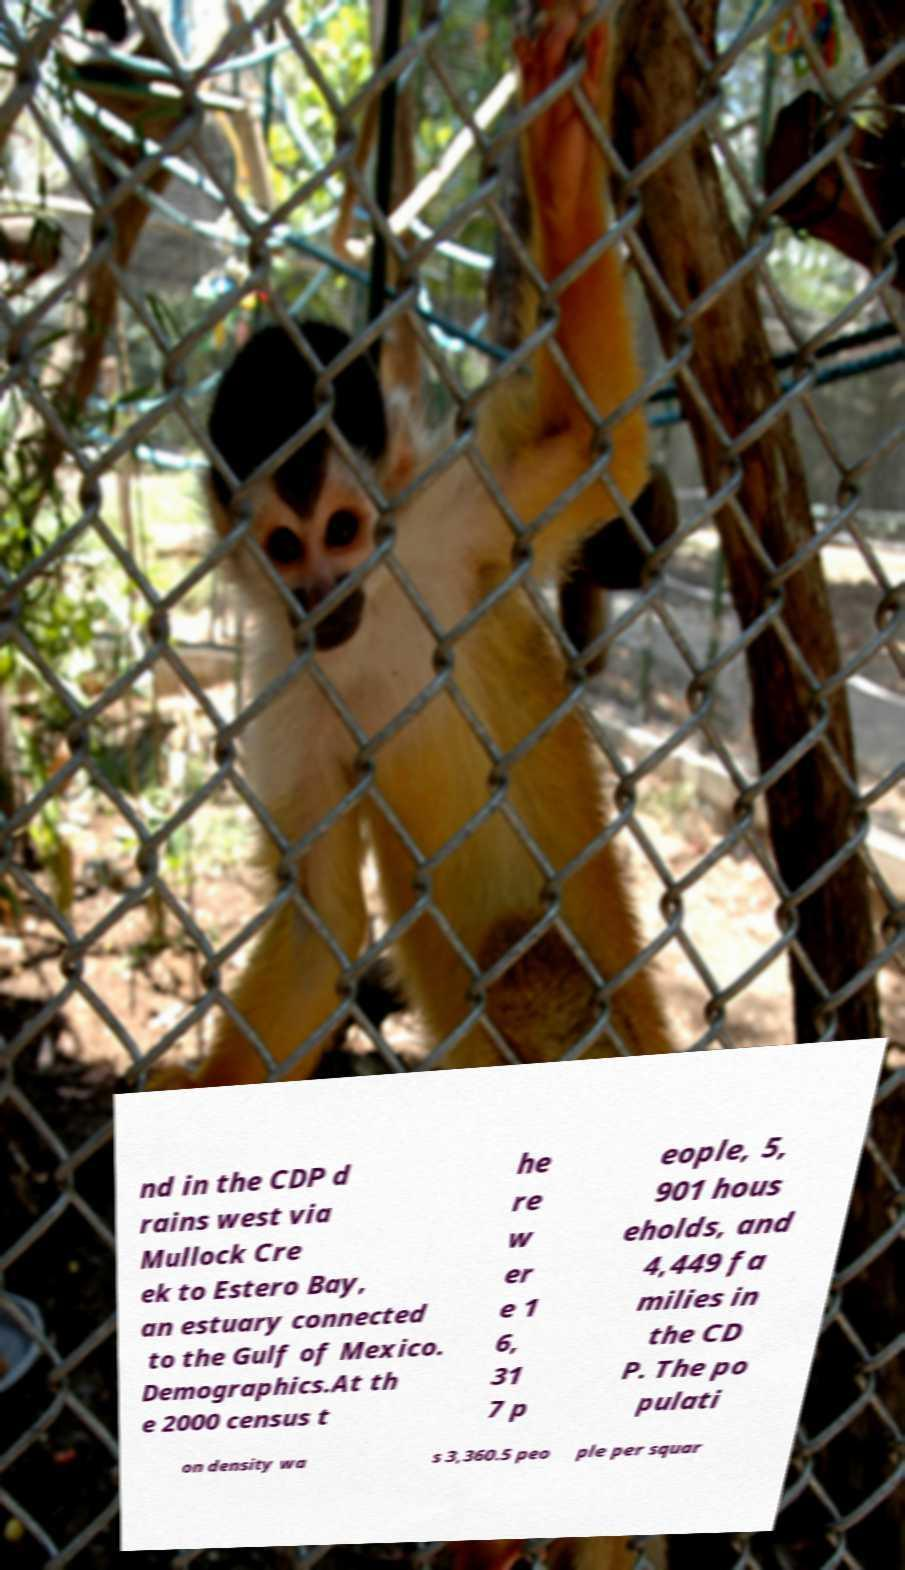Could you assist in decoding the text presented in this image and type it out clearly? nd in the CDP d rains west via Mullock Cre ek to Estero Bay, an estuary connected to the Gulf of Mexico. Demographics.At th e 2000 census t he re w er e 1 6, 31 7 p eople, 5, 901 hous eholds, and 4,449 fa milies in the CD P. The po pulati on density wa s 3,360.5 peo ple per squar 